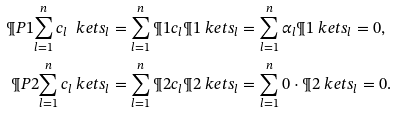<formula> <loc_0><loc_0><loc_500><loc_500>\P P { 1 } { \sum _ { l = 1 } ^ { n } c _ { l } \ k e t { s _ { l } } } & = \sum _ { l = 1 } ^ { n } \P { 1 } { c _ { l } } \P { 1 } { \ k e t { s _ { l } } } = \sum _ { l = 1 } ^ { n } \alpha _ { l } \P { 1 } { \ k e t { s _ { l } } } = 0 , \\ \P P { 2 } { \sum _ { l = 1 } ^ { n } c _ { l } \ k e t { s _ { l } } } & = \sum _ { l = 1 } ^ { n } \P { 2 } { c _ { l } } \P { 2 } { \ k e t { s _ { l } } } = \sum _ { l = 1 } ^ { n } 0 \cdot \P { 2 } { \ k e t { s _ { l } } } = 0 .</formula> 